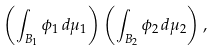Convert formula to latex. <formula><loc_0><loc_0><loc_500><loc_500>\left ( \int _ { B _ { 1 } } \phi _ { 1 } \, d \mu _ { 1 } \right ) \left ( \int _ { B _ { 2 } } \phi _ { 2 } \, d \mu _ { 2 } \right ) ,</formula> 